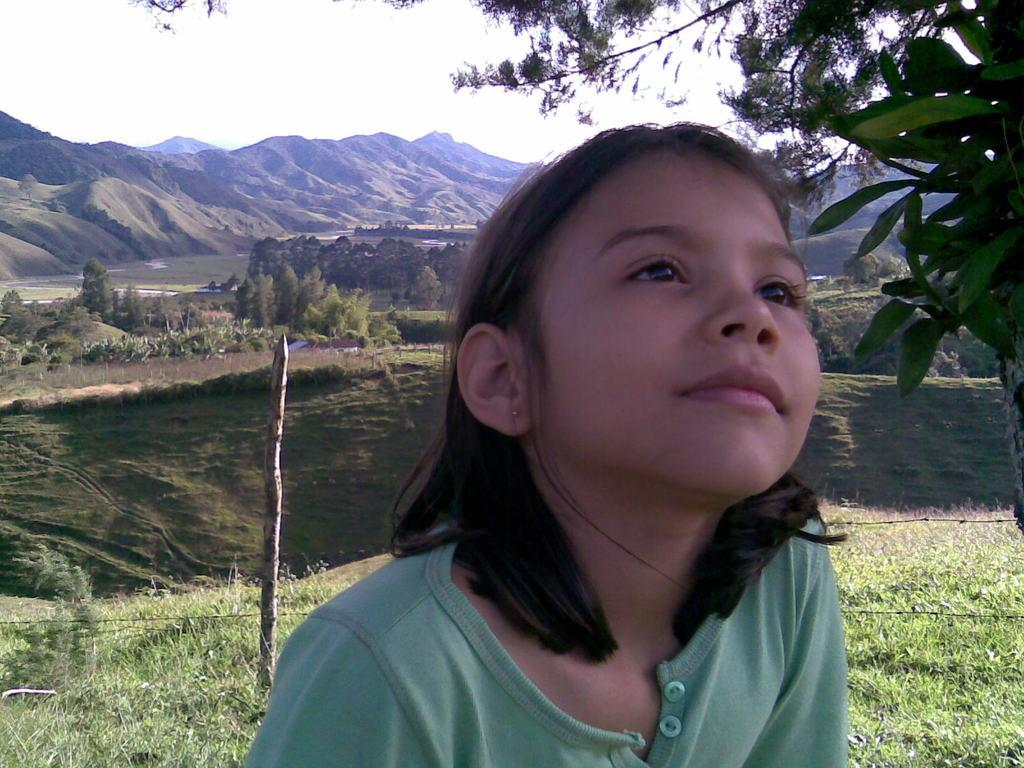Who is the main subject in the image? There is a girl in the image. What is the girl wearing? The girl is wearing a green T-shirt. What can be seen on the left side of the image? There is a pole on the left side of the image. What type of natural scenery is visible in the background of the image? There are trees, hills, and the sky visible in the background of the image. What type of print can be seen on the girl's T-shirt in the image? There is no print visible on the girl's green T-shirt in the image. What type of destruction is happening in the background of the image? There is no destruction visible in the image; it features a girl, a pole, and natural scenery in the background. 